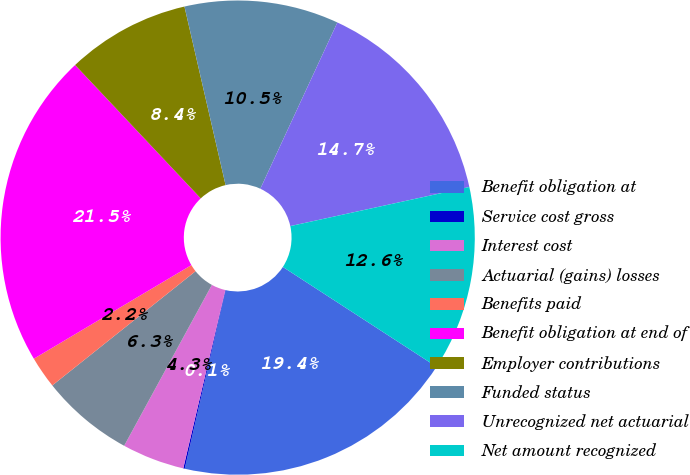<chart> <loc_0><loc_0><loc_500><loc_500><pie_chart><fcel>Benefit obligation at<fcel>Service cost gross<fcel>Interest cost<fcel>Actuarial (gains) losses<fcel>Benefits paid<fcel>Benefit obligation at end of<fcel>Employer contributions<fcel>Funded status<fcel>Unrecognized net actuarial<fcel>Net amount recognized<nl><fcel>19.42%<fcel>0.1%<fcel>4.26%<fcel>6.34%<fcel>2.18%<fcel>21.51%<fcel>8.42%<fcel>10.51%<fcel>14.67%<fcel>12.59%<nl></chart> 